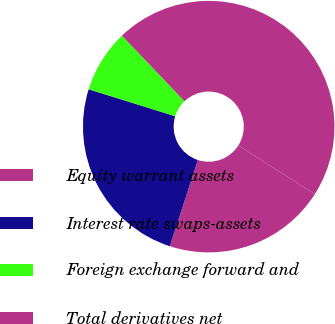Convert chart. <chart><loc_0><loc_0><loc_500><loc_500><pie_chart><fcel>Equity warrant assets<fcel>Interest rate swaps-assets<fcel>Foreign exchange forward and<fcel>Total derivatives net<nl><fcel>20.99%<fcel>24.8%<fcel>8.07%<fcel>46.14%<nl></chart> 